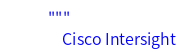Convert code to text. <code><loc_0><loc_0><loc_500><loc_500><_Python_>"""
    Cisco Intersight
</code> 